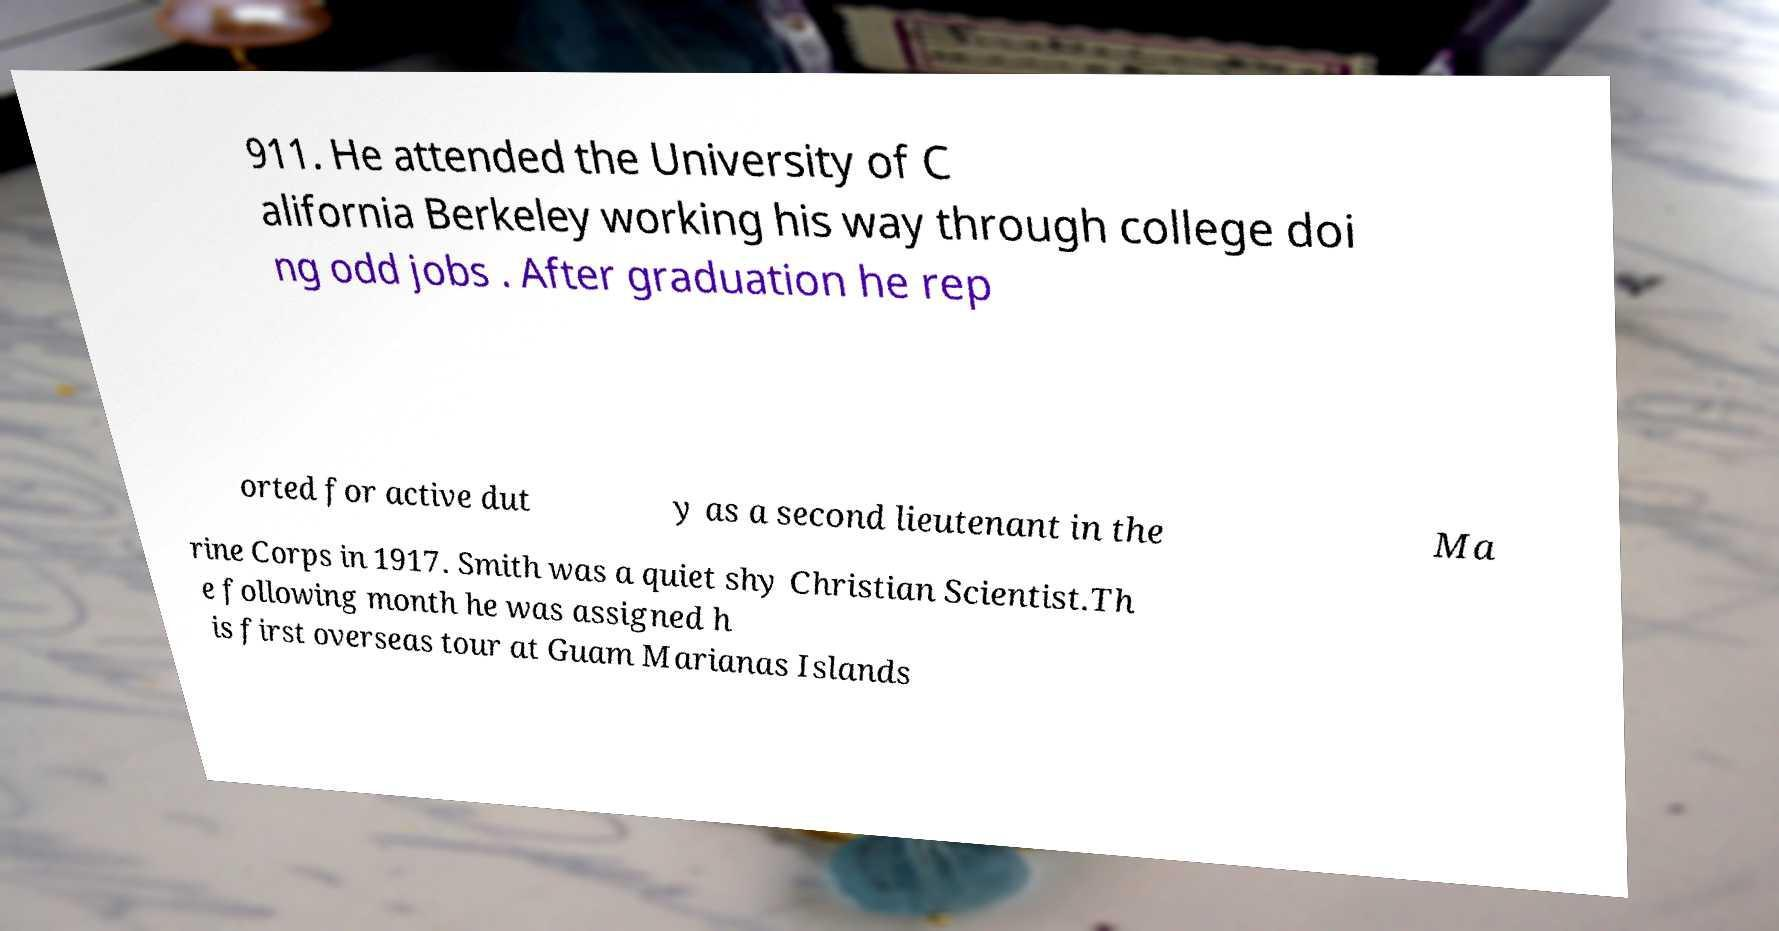Please read and relay the text visible in this image. What does it say? 911. He attended the University of C alifornia Berkeley working his way through college doi ng odd jobs . After graduation he rep orted for active dut y as a second lieutenant in the Ma rine Corps in 1917. Smith was a quiet shy Christian Scientist.Th e following month he was assigned h is first overseas tour at Guam Marianas Islands 